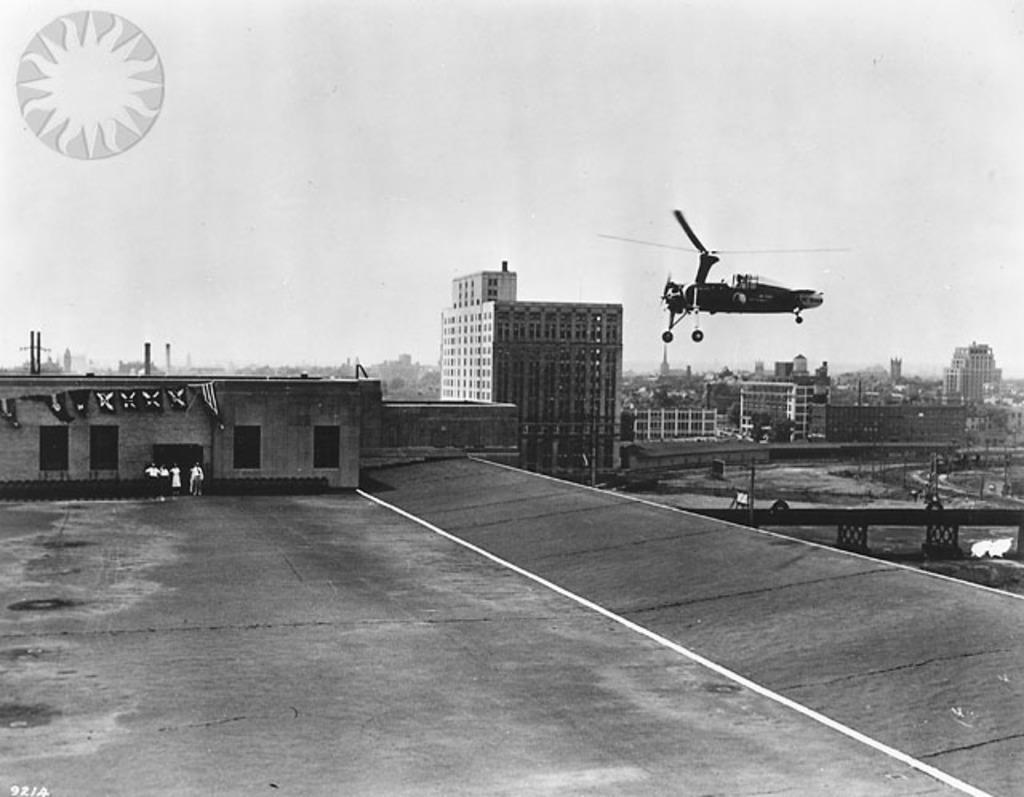In one or two sentences, can you explain what this image depicts? This is a black and white image and here we can see buildings, poles and towers. At the top, there is an airplane in the sky and we can see a logo on the top left. At the bottom, there is road. 